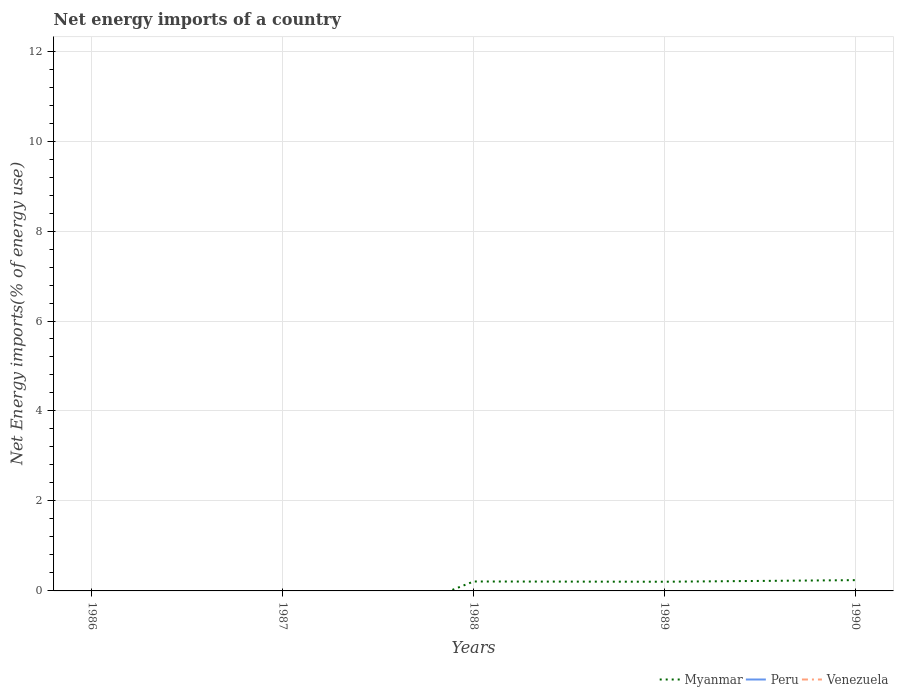Does the line corresponding to Peru intersect with the line corresponding to Myanmar?
Give a very brief answer. No. What is the total net energy imports in Myanmar in the graph?
Provide a succinct answer. -0.04. What is the difference between the highest and the second highest net energy imports in Myanmar?
Your response must be concise. 0.24. How many years are there in the graph?
Make the answer very short. 5. What is the difference between two consecutive major ticks on the Y-axis?
Your response must be concise. 2. How are the legend labels stacked?
Offer a very short reply. Horizontal. What is the title of the graph?
Your answer should be very brief. Net energy imports of a country. What is the label or title of the X-axis?
Offer a terse response. Years. What is the label or title of the Y-axis?
Make the answer very short. Net Energy imports(% of energy use). What is the Net Energy imports(% of energy use) in Venezuela in 1986?
Your response must be concise. 0. What is the Net Energy imports(% of energy use) of Myanmar in 1987?
Keep it short and to the point. 0. What is the Net Energy imports(% of energy use) of Myanmar in 1988?
Your response must be concise. 0.21. What is the Net Energy imports(% of energy use) of Peru in 1988?
Ensure brevity in your answer.  0. What is the Net Energy imports(% of energy use) of Venezuela in 1988?
Your answer should be very brief. 0. What is the Net Energy imports(% of energy use) in Myanmar in 1989?
Provide a succinct answer. 0.2. What is the Net Energy imports(% of energy use) of Peru in 1989?
Your response must be concise. 0. What is the Net Energy imports(% of energy use) of Myanmar in 1990?
Provide a short and direct response. 0.24. Across all years, what is the maximum Net Energy imports(% of energy use) of Myanmar?
Your answer should be compact. 0.24. What is the total Net Energy imports(% of energy use) of Myanmar in the graph?
Ensure brevity in your answer.  0.65. What is the difference between the Net Energy imports(% of energy use) of Myanmar in 1988 and that in 1989?
Keep it short and to the point. 0.01. What is the difference between the Net Energy imports(% of energy use) in Myanmar in 1988 and that in 1990?
Keep it short and to the point. -0.03. What is the difference between the Net Energy imports(% of energy use) of Myanmar in 1989 and that in 1990?
Provide a succinct answer. -0.04. What is the average Net Energy imports(% of energy use) of Myanmar per year?
Provide a short and direct response. 0.13. What is the ratio of the Net Energy imports(% of energy use) of Myanmar in 1988 to that in 1989?
Provide a short and direct response. 1.03. What is the ratio of the Net Energy imports(% of energy use) in Myanmar in 1989 to that in 1990?
Your answer should be compact. 0.85. What is the difference between the highest and the lowest Net Energy imports(% of energy use) in Myanmar?
Make the answer very short. 0.24. 